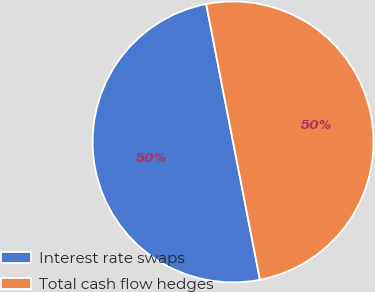<chart> <loc_0><loc_0><loc_500><loc_500><pie_chart><fcel>Interest rate swaps<fcel>Total cash flow hedges<nl><fcel>50.0%<fcel>50.0%<nl></chart> 